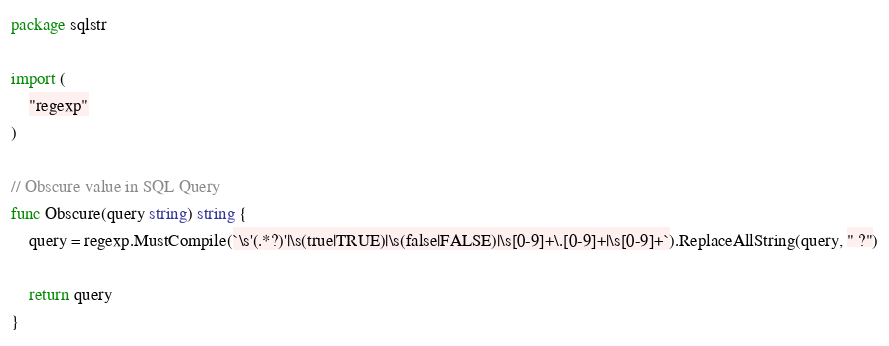<code> <loc_0><loc_0><loc_500><loc_500><_Go_>package sqlstr

import (
	"regexp"
)

// Obscure value in SQL Query
func Obscure(query string) string {
	query = regexp.MustCompile(`\s'(.*?)'|\s(true|TRUE)|\s(false|FALSE)|\s[0-9]+\.[0-9]+|\s[0-9]+`).ReplaceAllString(query, " ?")

	return query
}
</code> 